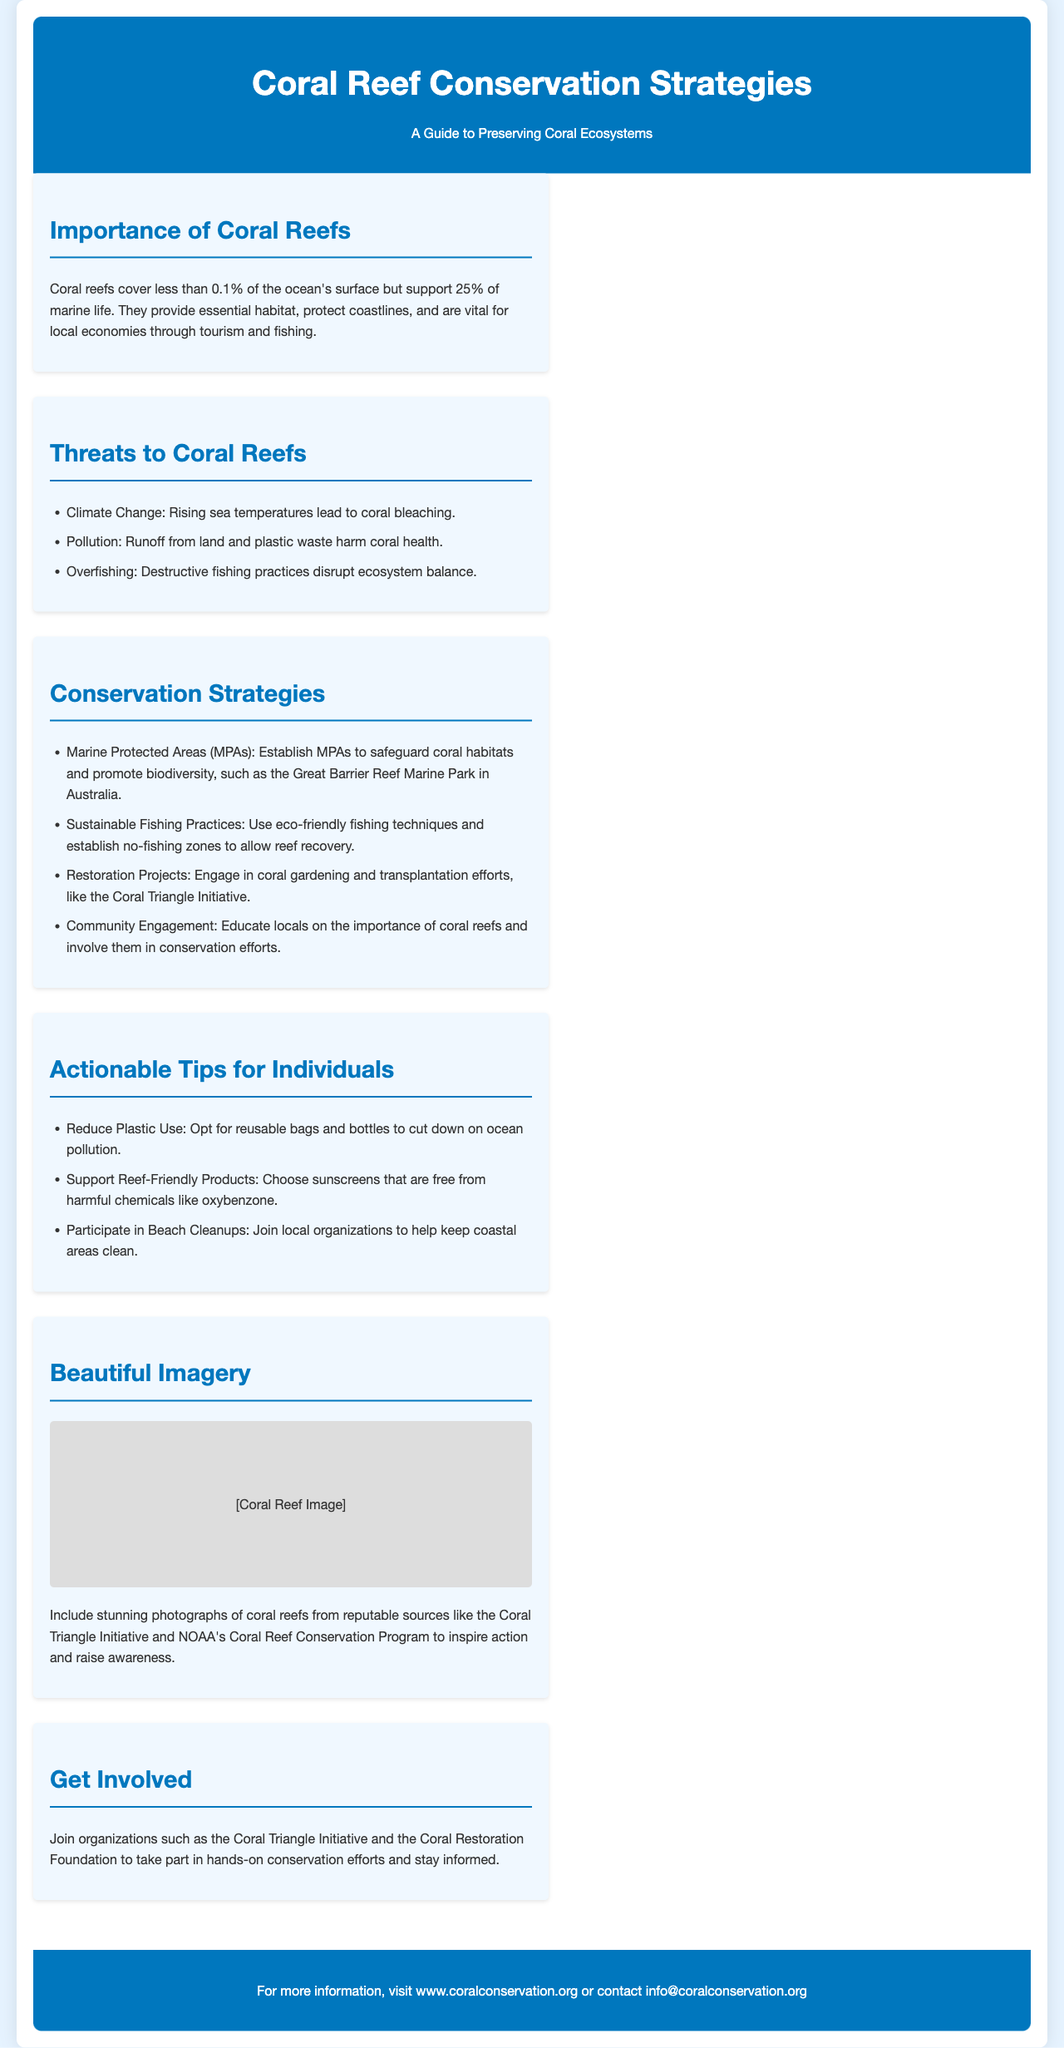What percentage of marine life relies on coral reefs? Coral reefs support 25% of marine life as stated in the document.
Answer: 25% What is one of the threats to coral reefs mentioned? The document lists several threats, one of which is rising sea temperatures leading to coral bleaching.
Answer: Climate Change What are Marine Protected Areas designed to do? The document states that MPAs are established to safeguard coral habitats and promote biodiversity.
Answer: Safeguard coral habitats What is a tip provided for individuals to help coral conservation? The document provides actionable tips, one of which is to opt for reusable bags and bottles.
Answer: Reduce Plastic Use Which organizations can people join to get involved in coral conservation? The document mentions the Coral Triangle Initiative and the Coral Restoration Foundation as organizations for involvement.
Answer: Coral Triangle Initiative What is the main background color of the brochure? The document describes the background color as light blue (#e6f3ff).
Answer: Light blue What type of imagery is included in the brochure? The document indicates that beautiful photographs of coral reefs are included to inspire action.
Answer: Coral reef photographs What do sustainable fishing practices help achieve? The document explains that sustainable fishing practices help allow reef recovery.
Answer: Allow reef recovery What is the footer primarily providing? The footer of the document is providing contact information and a website for more information.
Answer: Contact information 